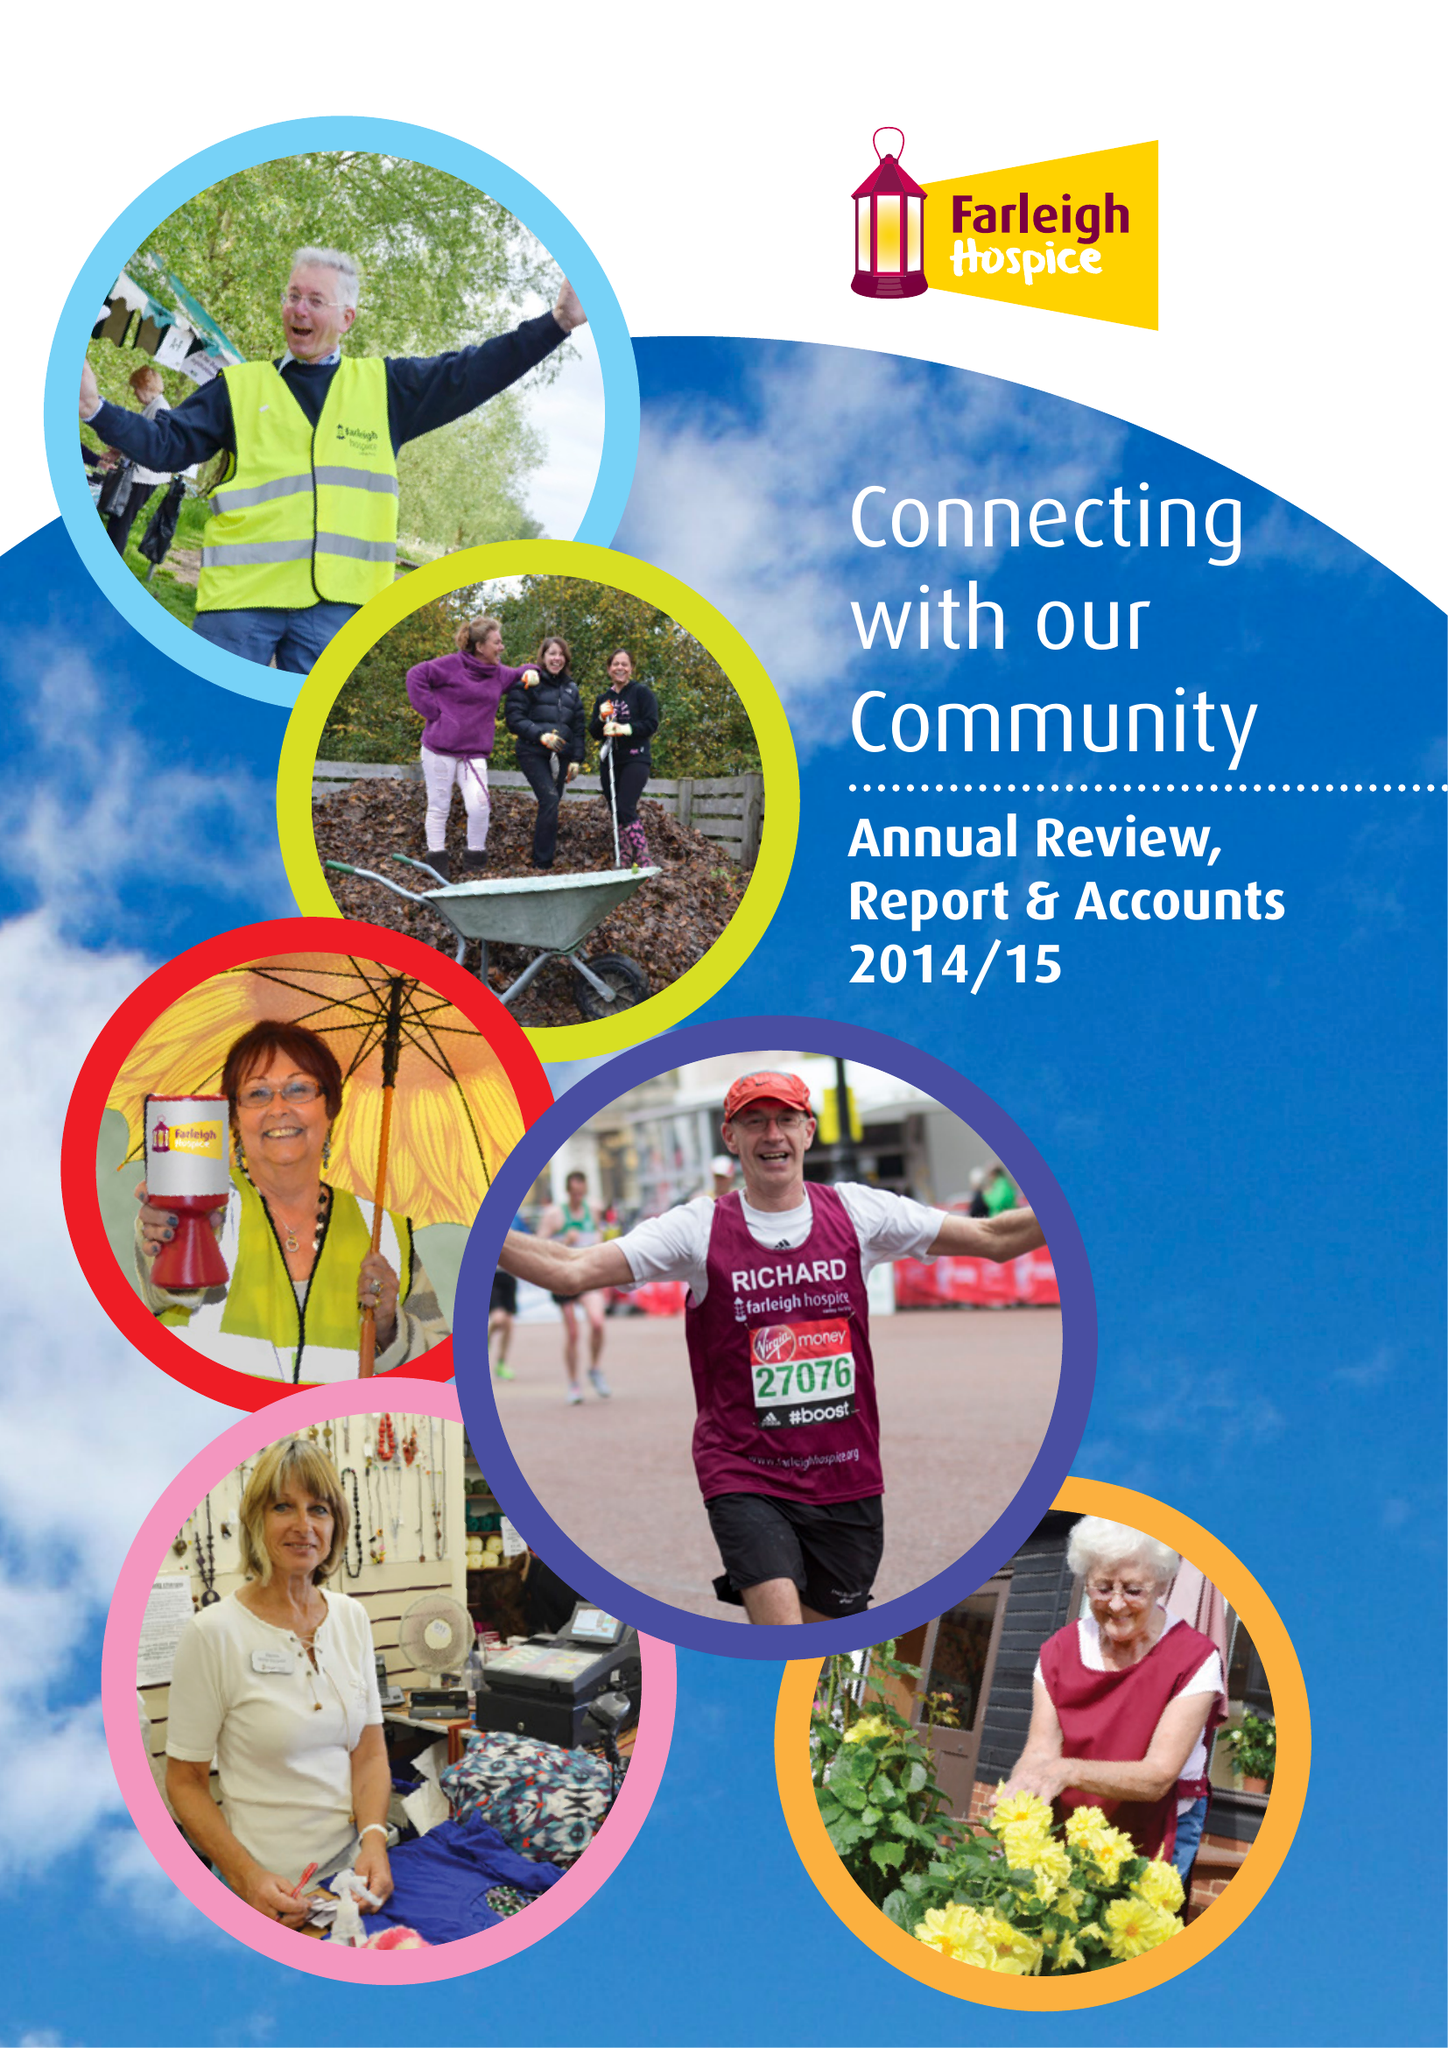What is the value for the charity_name?
Answer the question using a single word or phrase. Farleigh Hospice 